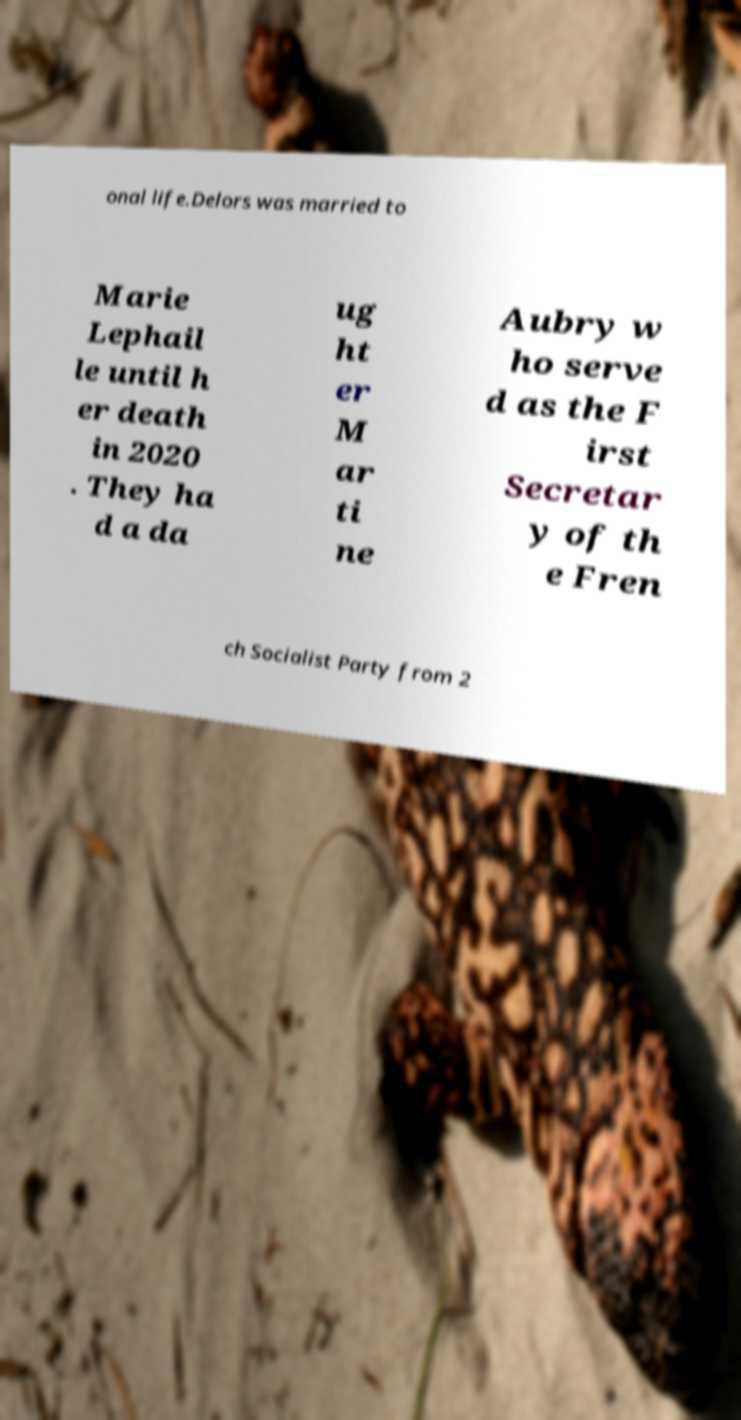For documentation purposes, I need the text within this image transcribed. Could you provide that? onal life.Delors was married to Marie Lephail le until h er death in 2020 . They ha d a da ug ht er M ar ti ne Aubry w ho serve d as the F irst Secretar y of th e Fren ch Socialist Party from 2 